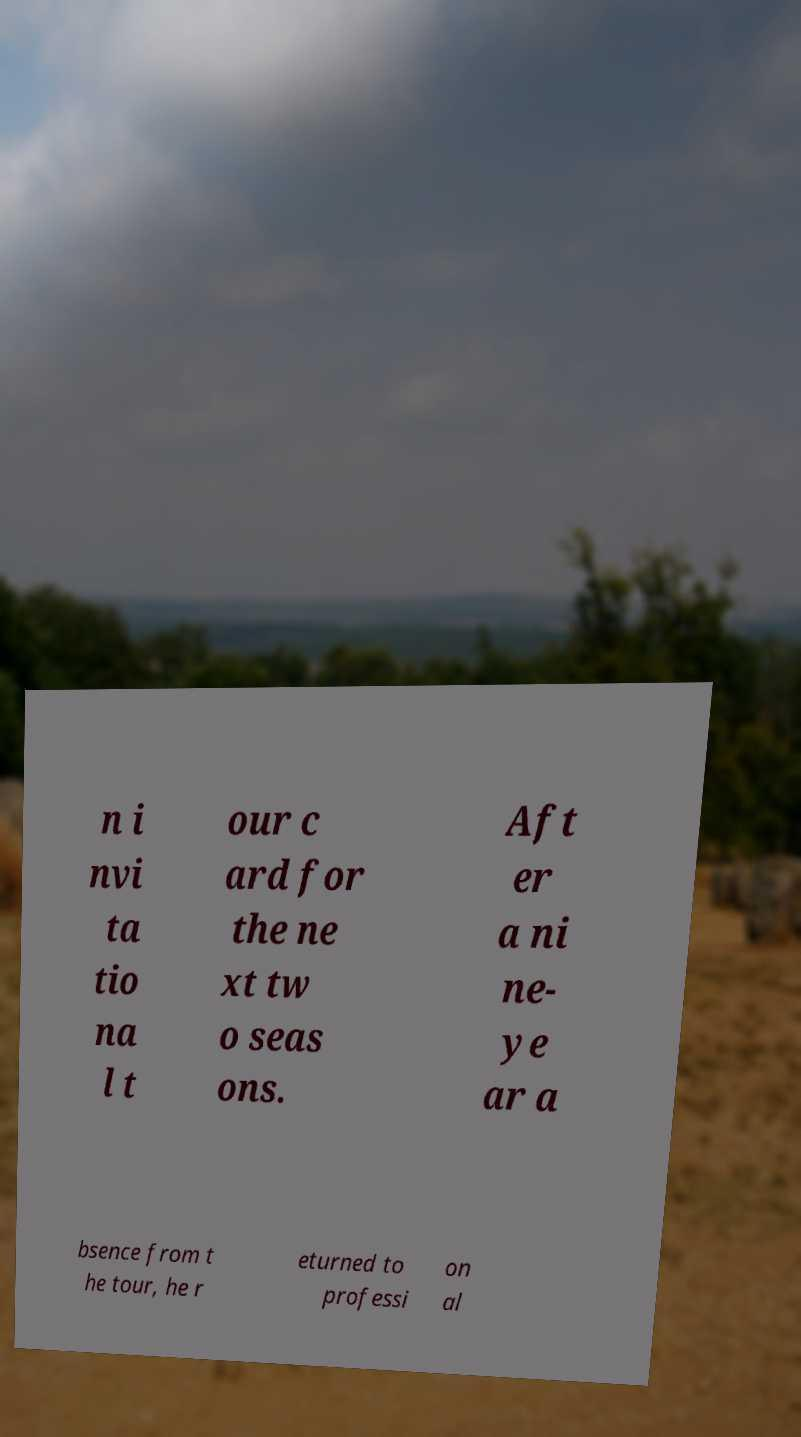I need the written content from this picture converted into text. Can you do that? n i nvi ta tio na l t our c ard for the ne xt tw o seas ons. Aft er a ni ne- ye ar a bsence from t he tour, he r eturned to professi on al 